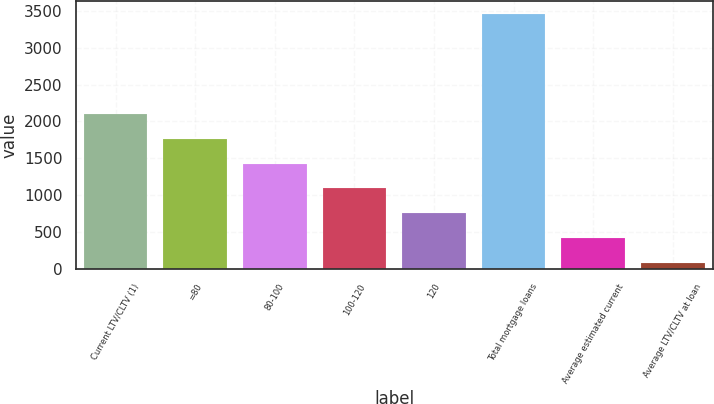Convert chart to OTSL. <chart><loc_0><loc_0><loc_500><loc_500><bar_chart><fcel>Current LTV/CLTV (1)<fcel>=80<fcel>80-100<fcel>100-120<fcel>120<fcel>Total mortgage loans<fcel>Average estimated current<fcel>Average LTV/CLTV at loan<nl><fcel>2104.4<fcel>1767<fcel>1429.6<fcel>1092.2<fcel>754.8<fcel>3454<fcel>417.4<fcel>80<nl></chart> 